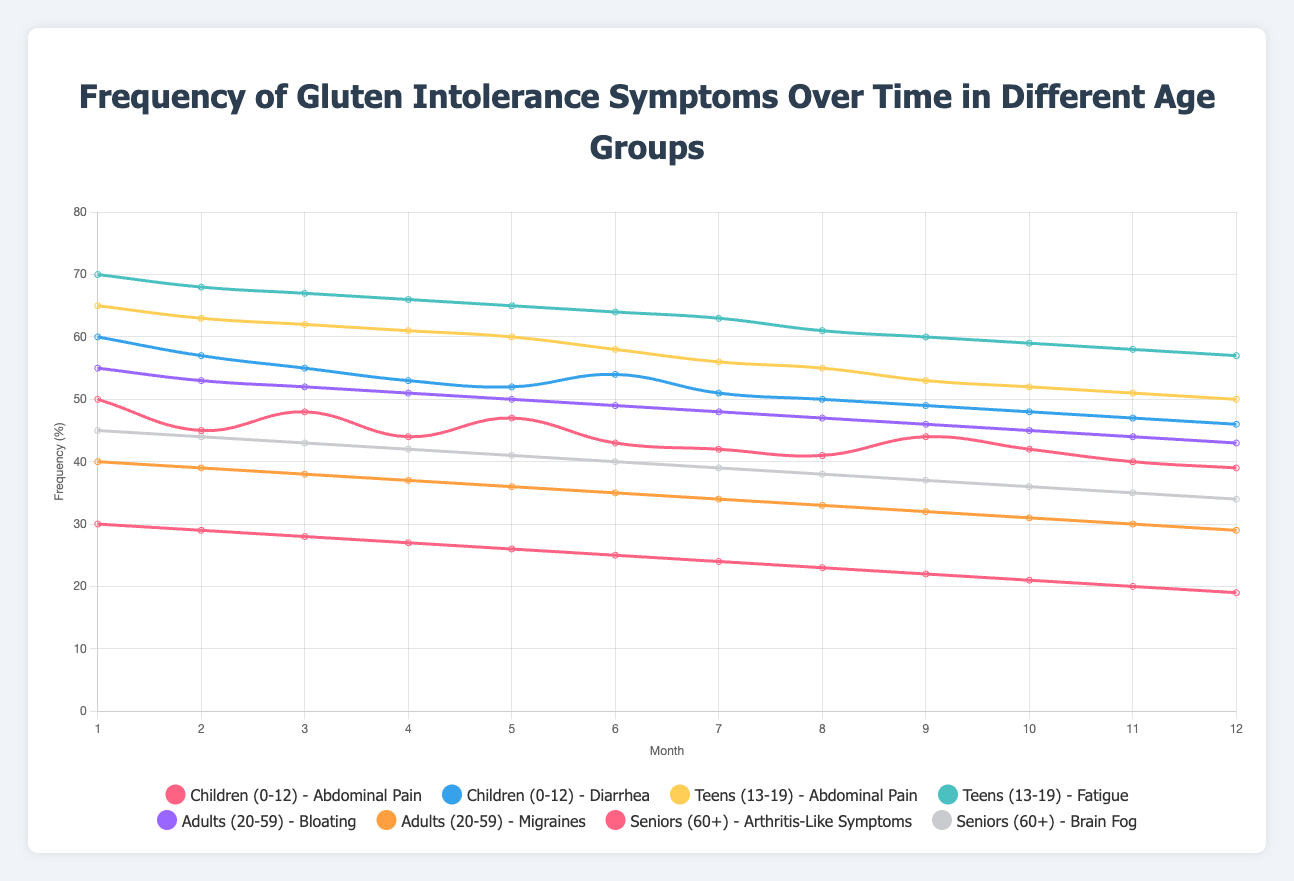What is the overall trend of 'Abdominal Pain' frequency in children over the 12 months? The frequency of 'Abdominal Pain' in children starts high at 50% and shows a gradual declining trend over the 12 months, ending at 39%.
Answer: Gradual decline Which symptom has the highest initial frequency in the Teens (13-19) age group? In the Teens age group, 'Fatigue' has the highest initial frequency at 70%, compared to 'Abdominal Pain' which starts at 65%.
Answer: Fatigue Between 'Migraines' in Adults (20-59) and 'Brain Fog' in Seniors (60+), which symptom shows a greater percentage drop from month 1 to month 12? 'Migraines' in Adults (20-59) drop from 40% to 29%, which is an 11% decrease. 'Brain Fog' in Seniors (60+) drop from 45% to 34%, also an 11% decrease. Therefore, both symptoms show the same percentage drop over the 12 months.
Answer: Same percentage drop In which age group and symptom combination does the symptom frequency start at the lowest value? 'Arthritis-Like Symptoms' in Seniors (60+) start at the lowest value of 30% among all age groups and symptoms.
Answer: Arthritis-Like Symptoms in Seniors What symptom shows the least fluctuation in frequency over the 12 months in the Children (0-12) age group? 'Diarrhea' in Children shows less fluctuation, starting at 60% and ending at 46%, compared to 'Abdominal Pain' which fluctuates more.
Answer: Diarrhea How does the trend of 'Bloating' in Adults (20-59) compare to the trend of 'Brain Fog' in Seniors (60+)? The trend of 'Bloating' in Adults shows a consistent decrement from 55% to 43%. The 'Brain Fog' trend in Seniors is similar, with a decrement from 45% to 34%. Both show a steady decrease, but 'Bloating' starts higher and ends higher.
Answer: Both show a steady decrease Considering only the symptoms related to gastrointestinal issues (e.g., Abdominal Pain, Diarrhea, Bloating), which age group starts with the highest frequency? Teens (13-19) start with 65% for 'Abdominal Pain', making it the highest starting frequency for gastrointestinal symptoms among the age groups.
Answer: Teens (13-19) Which month shows the highest increase in 'Abdominal Pain' frequency in children and by how much? In month 3, 'Abdominal Pain' frequency in children increases from 45% to 48%, showing the highest rise of 3%.
Answer: Month 3, increase by 3% What is the combined frequency of 'Abdominal Pain' and 'Diarrhea' in children at month 6? At month 6, 'Abdominal Pain' is 43% and 'Diarrhea' is 54%. The combined frequency is 43% + 54% = 97%.
Answer: 97% Which symptom in the Teens age group shows the most rapid decline after month 1? 'Fatigue' in Teens shows a rapid decline from 70% to 68% within one month, and then continues to decline steadily.
Answer: Fatigue 